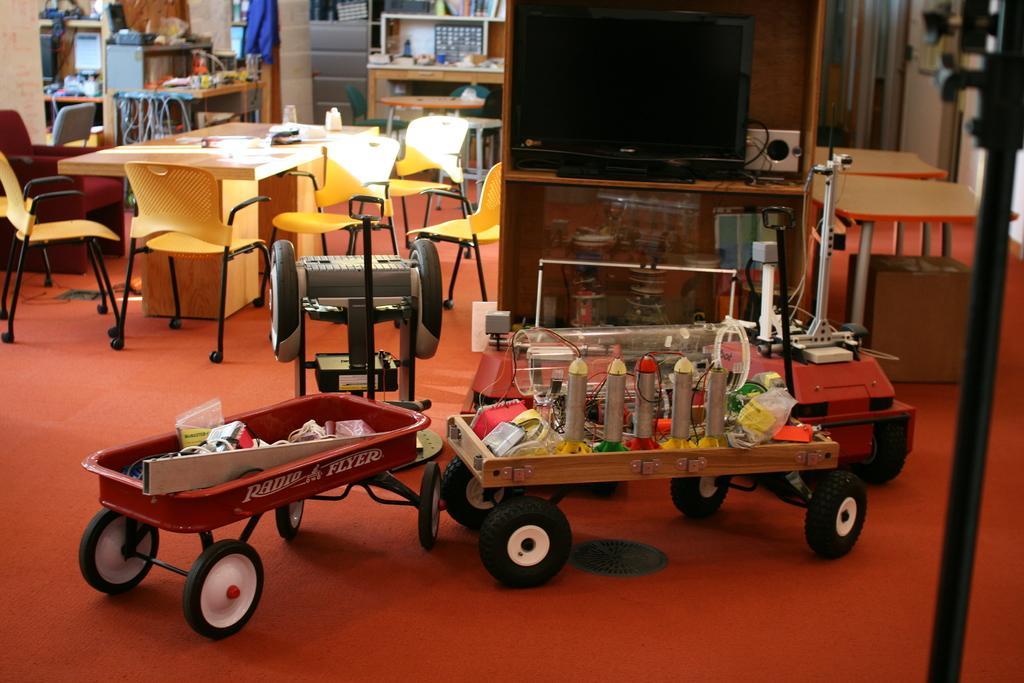Can you describe this image briefly? The image is taken in the room. In the center of the image there is a television placed on the stand. At the bottom there is a toy. In the background there is a table, chairs, wall and clothes. 